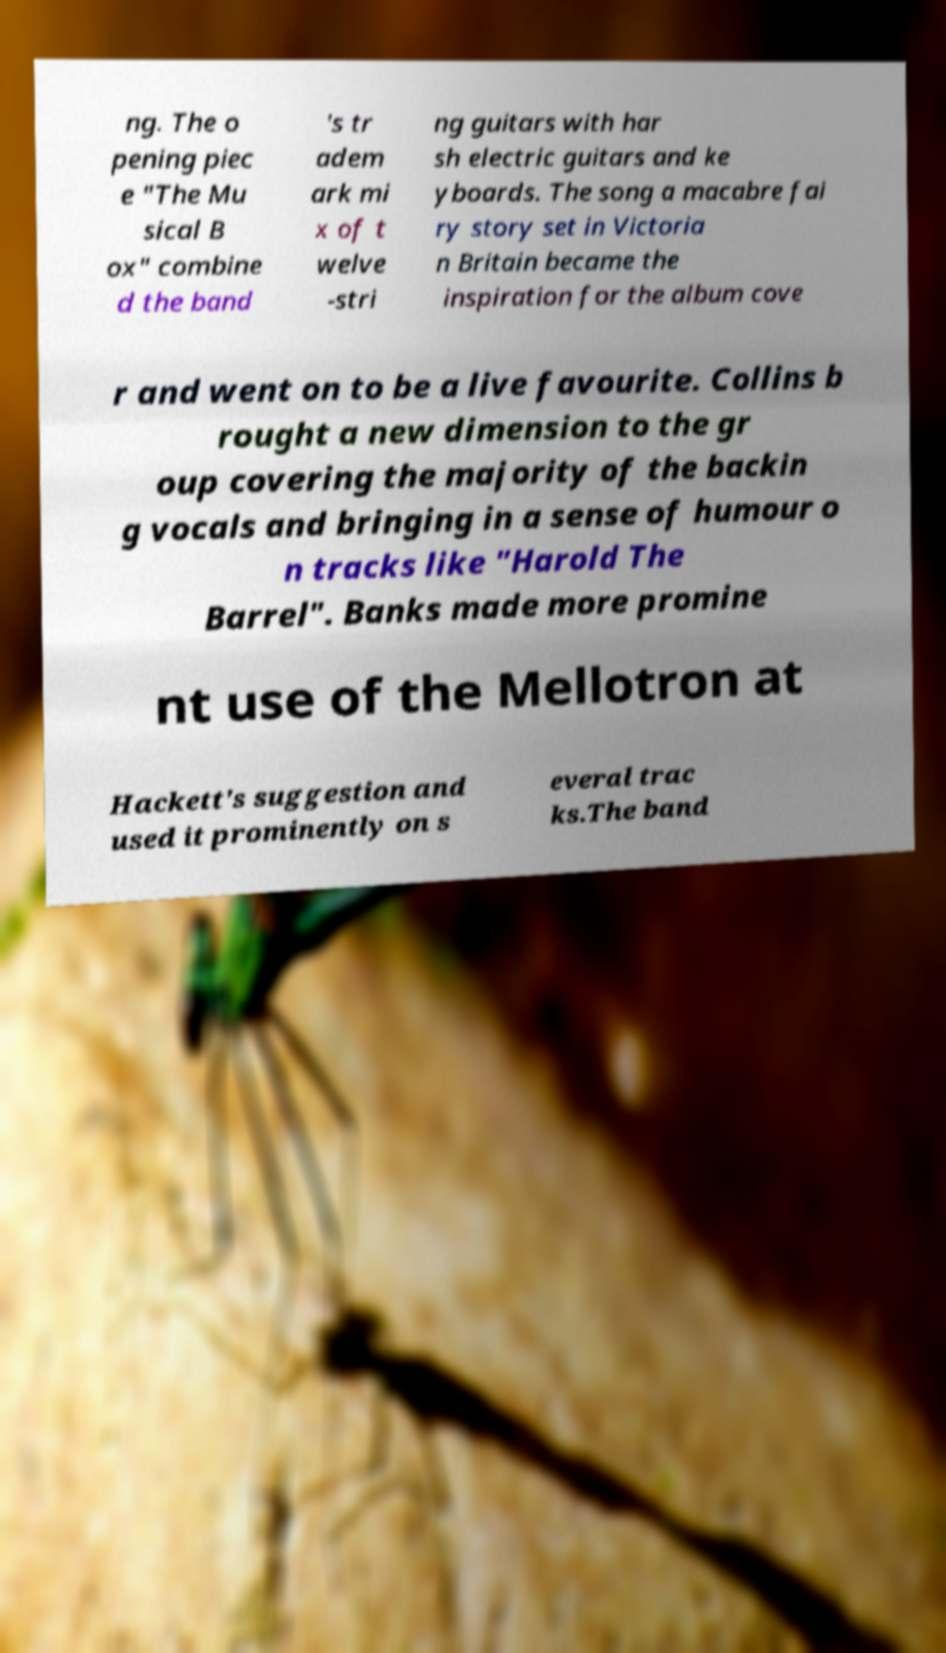Can you read and provide the text displayed in the image?This photo seems to have some interesting text. Can you extract and type it out for me? ng. The o pening piec e "The Mu sical B ox" combine d the band 's tr adem ark mi x of t welve -stri ng guitars with har sh electric guitars and ke yboards. The song a macabre fai ry story set in Victoria n Britain became the inspiration for the album cove r and went on to be a live favourite. Collins b rought a new dimension to the gr oup covering the majority of the backin g vocals and bringing in a sense of humour o n tracks like "Harold The Barrel". Banks made more promine nt use of the Mellotron at Hackett's suggestion and used it prominently on s everal trac ks.The band 